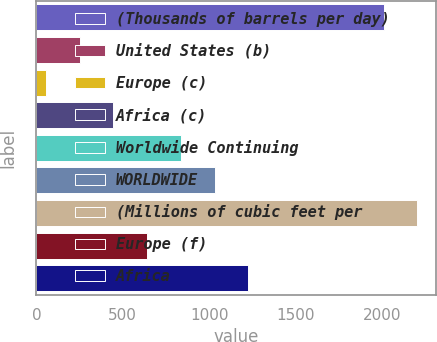Convert chart. <chart><loc_0><loc_0><loc_500><loc_500><bar_chart><fcel>(Thousands of barrels per day)<fcel>United States (b)<fcel>Europe (c)<fcel>Africa (c)<fcel>Worldwide Continuing<fcel>WORLDWIDE<fcel>(Millions of cubic feet per<fcel>Europe (f)<fcel>Africa<nl><fcel>2008<fcel>250.3<fcel>55<fcel>445.6<fcel>836.2<fcel>1031.5<fcel>2203.3<fcel>640.9<fcel>1226.8<nl></chart> 